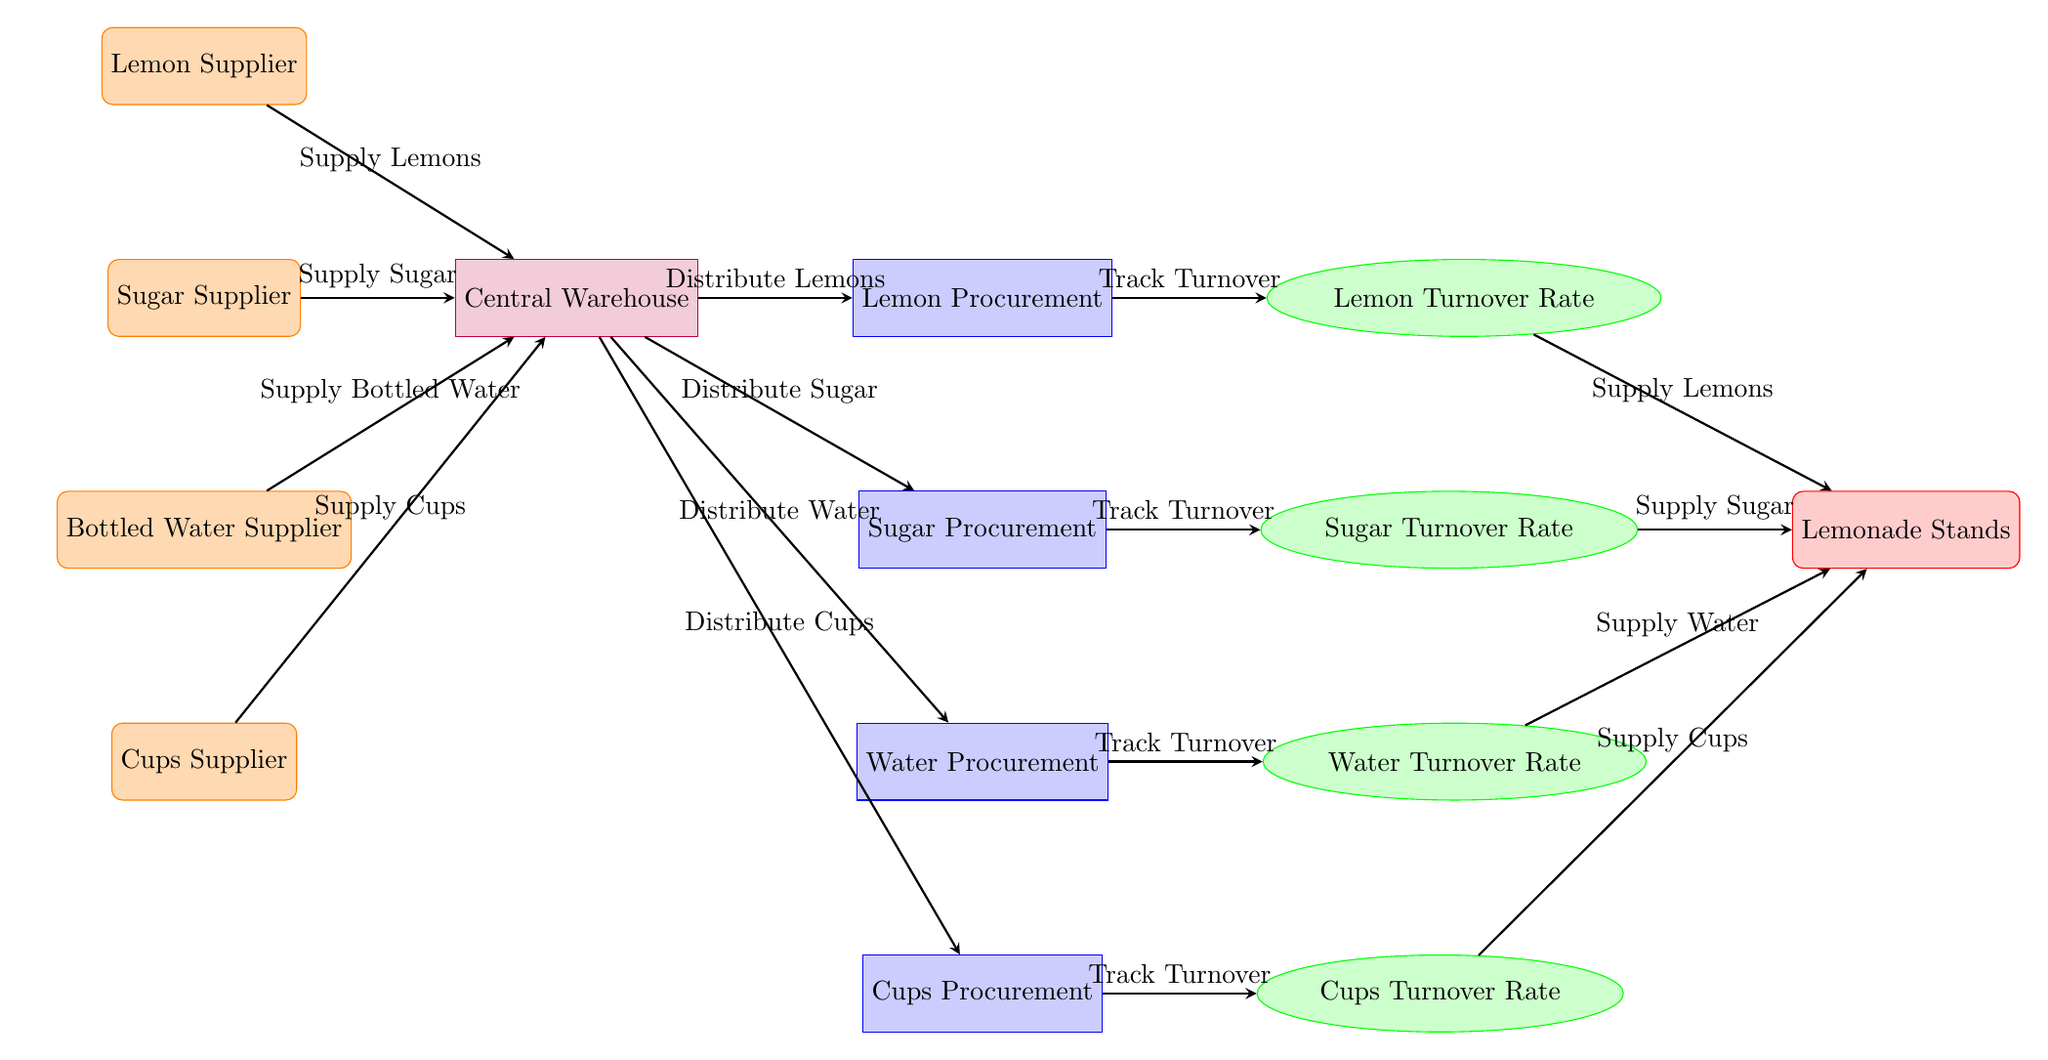What is the total number of suppliers in the diagram? The diagram shows four distinct suppliers: Lemon Supplier, Sugar Supplier, Bottled Water Supplier, and Cups Supplier. By counting these suppliers, we tally a total of 4.
Answer: 4 What color represents the procurement processes in the diagram? The procurement processes are depicted in blue with a light blue fill according to the node style defined in the diagram.
Answer: Blue Which supplier is associated with the procurement of sugar? The supplier associated with sugar procurement is specifically labeled as "Sugar Supplier" in the diagram.
Answer: Sugar Supplier How many types of turnover rates are indicated in the diagram? The diagram shows four turnover rates corresponding to each supply type: Lemon Turnover Rate, Sugar Turnover Rate, Water Turnover Rate, and Cups Turnover Rate. Thus, there are 4 types of turnover rates indicated.
Answer: 4 What is the relationship between the Central Warehouse and the Lemon Procurement process? The relationship is that the Central Warehouse distributes the lemons to the Lemon Procurement process. This is depicted by a directional arrow labeled "Distribute Lemons" that points from the warehouse to the lemon procurement node.
Answer: Distribute Lemons Which node receives supplies from the turnover rates? The node labeled "Lemonade Stands" receives supplies from all four turnover rates, indicating that it gets lemons, sugar, water, and cups based on their respective turnover rates.
Answer: Lemonade Stands What type of diagram is represented here? This is a Detailed Inventory Management Diagram that illustrates components such as suppliers, procurement processes, and turnover rates specifically for a lemonade stand.
Answer: Detailed Inventory Management Diagram Which procurement process tracks the turnover of water? The "Water Procurement" process is responsible for tracking the turnover of water, as indicated by the arrow labeled "Track Turnover" pointing towards the Water Turnover Rate.
Answer: Water Procurement 